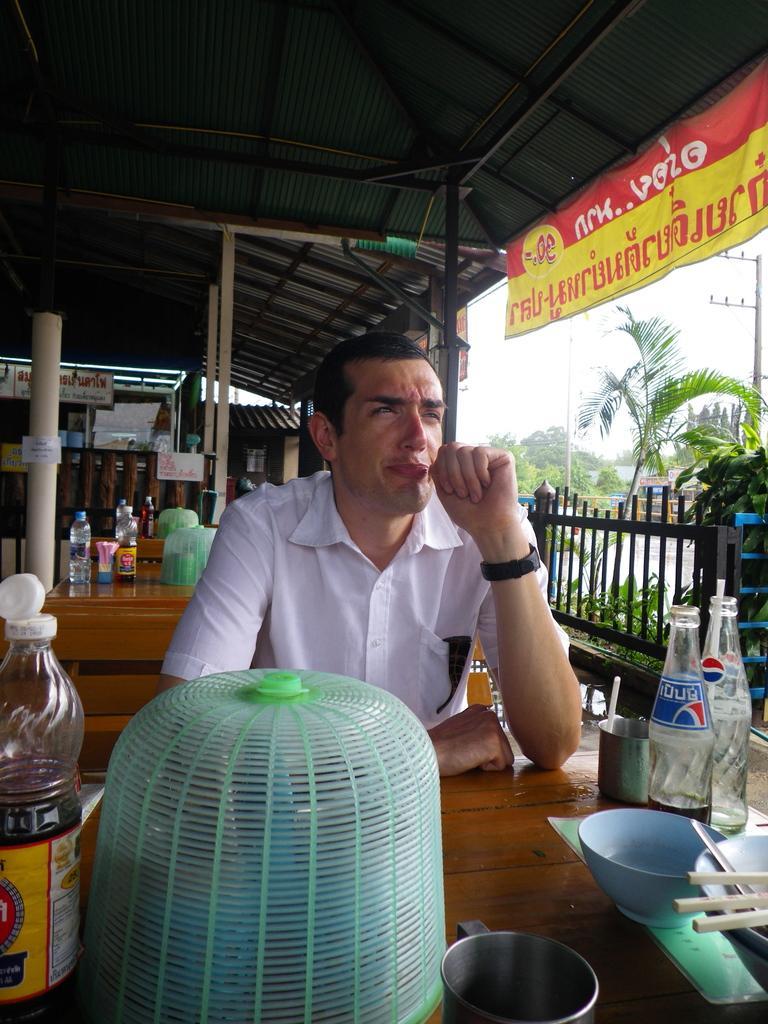How would you summarize this image in a sentence or two? This image consists of tables ,trees on right side ,a banner on right side top corner. This is a shed. On that table there are cold drinks ,bowls, chopsticks, water bottles. There is a person sitting on chair near this table. 